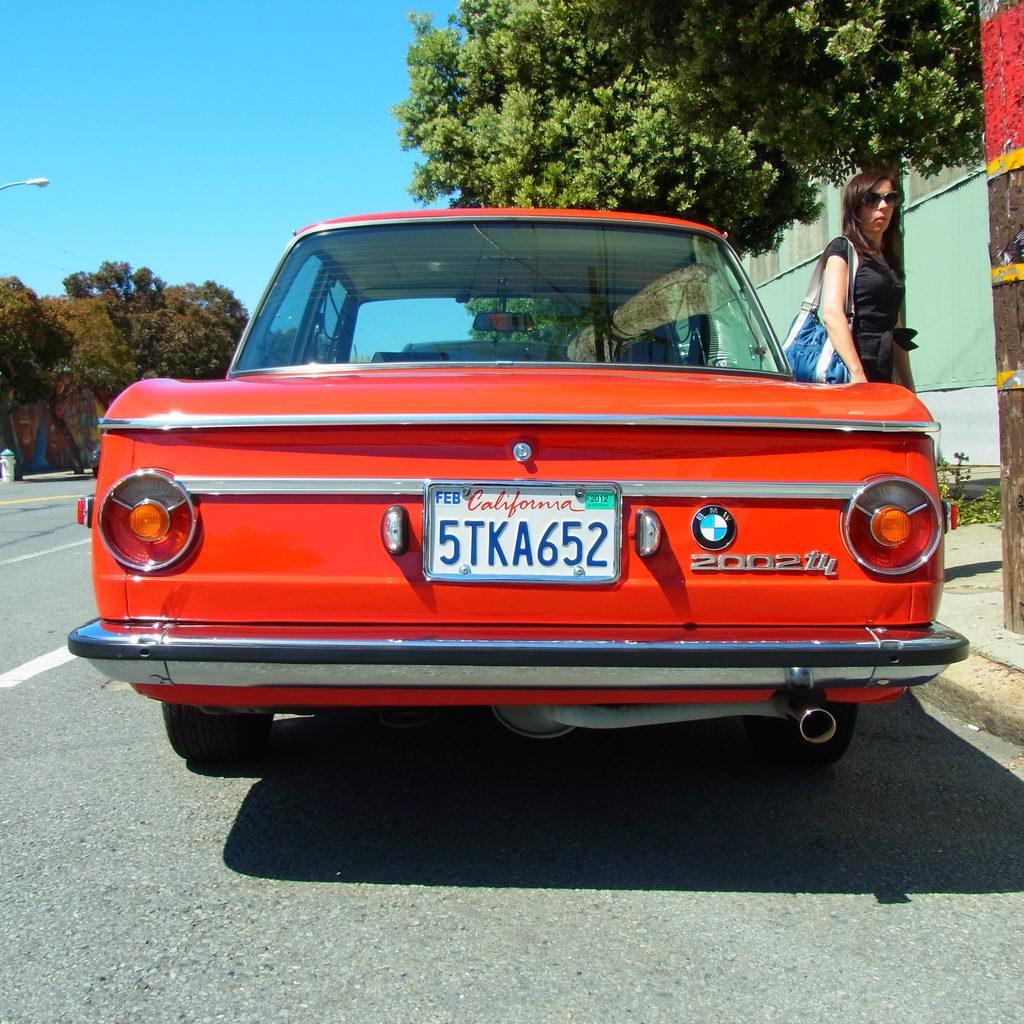Please provide a concise description of this image. In this image we can see there is the car on the road and there is the person walking. And there are trees, walls and the sky. And there is a white color object. 